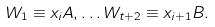Convert formula to latex. <formula><loc_0><loc_0><loc_500><loc_500>W _ { 1 } \equiv x _ { i } A , \dots W _ { t + 2 } \equiv x _ { i + 1 } B .</formula> 